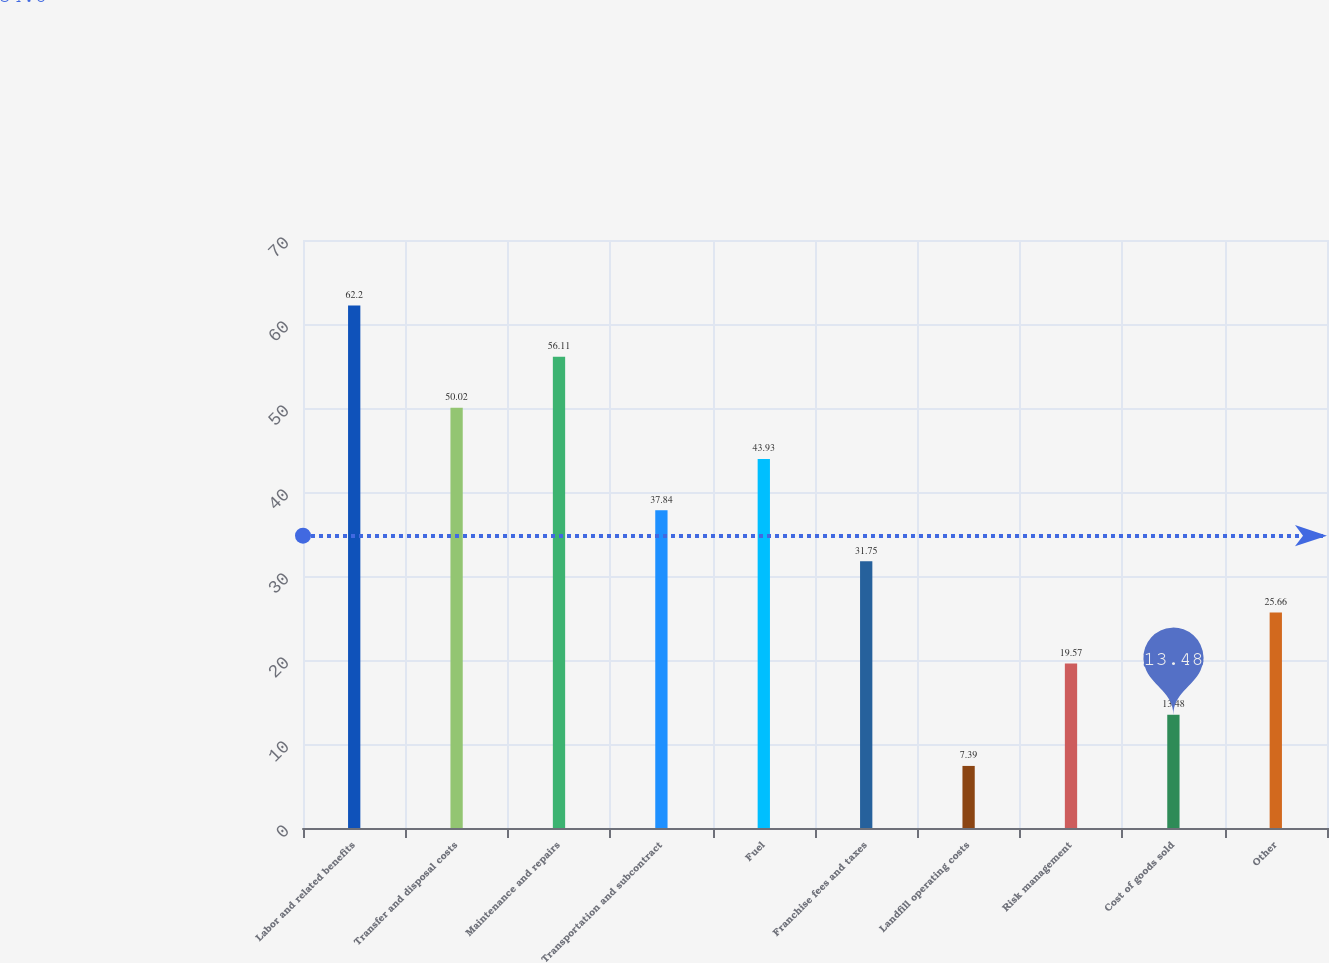<chart> <loc_0><loc_0><loc_500><loc_500><bar_chart><fcel>Labor and related benefits<fcel>Transfer and disposal costs<fcel>Maintenance and repairs<fcel>Transportation and subcontract<fcel>Fuel<fcel>Franchise fees and taxes<fcel>Landfill operating costs<fcel>Risk management<fcel>Cost of goods sold<fcel>Other<nl><fcel>62.2<fcel>50.02<fcel>56.11<fcel>37.84<fcel>43.93<fcel>31.75<fcel>7.39<fcel>19.57<fcel>13.48<fcel>25.66<nl></chart> 